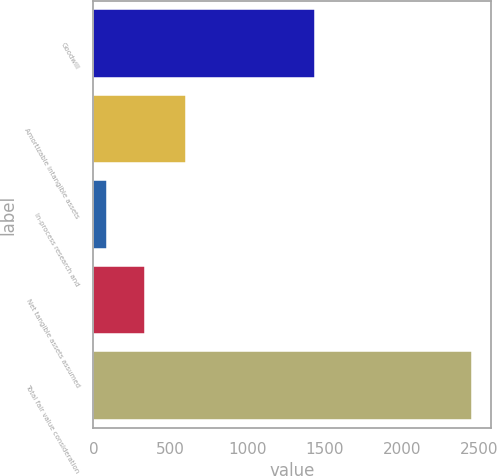Convert chart. <chart><loc_0><loc_0><loc_500><loc_500><bar_chart><fcel>Goodwill<fcel>Amortizable intangible assets<fcel>In-process research and<fcel>Net tangible assets assumed<fcel>Total fair value consideration<nl><fcel>1433<fcel>603<fcel>85<fcel>334<fcel>2455<nl></chart> 